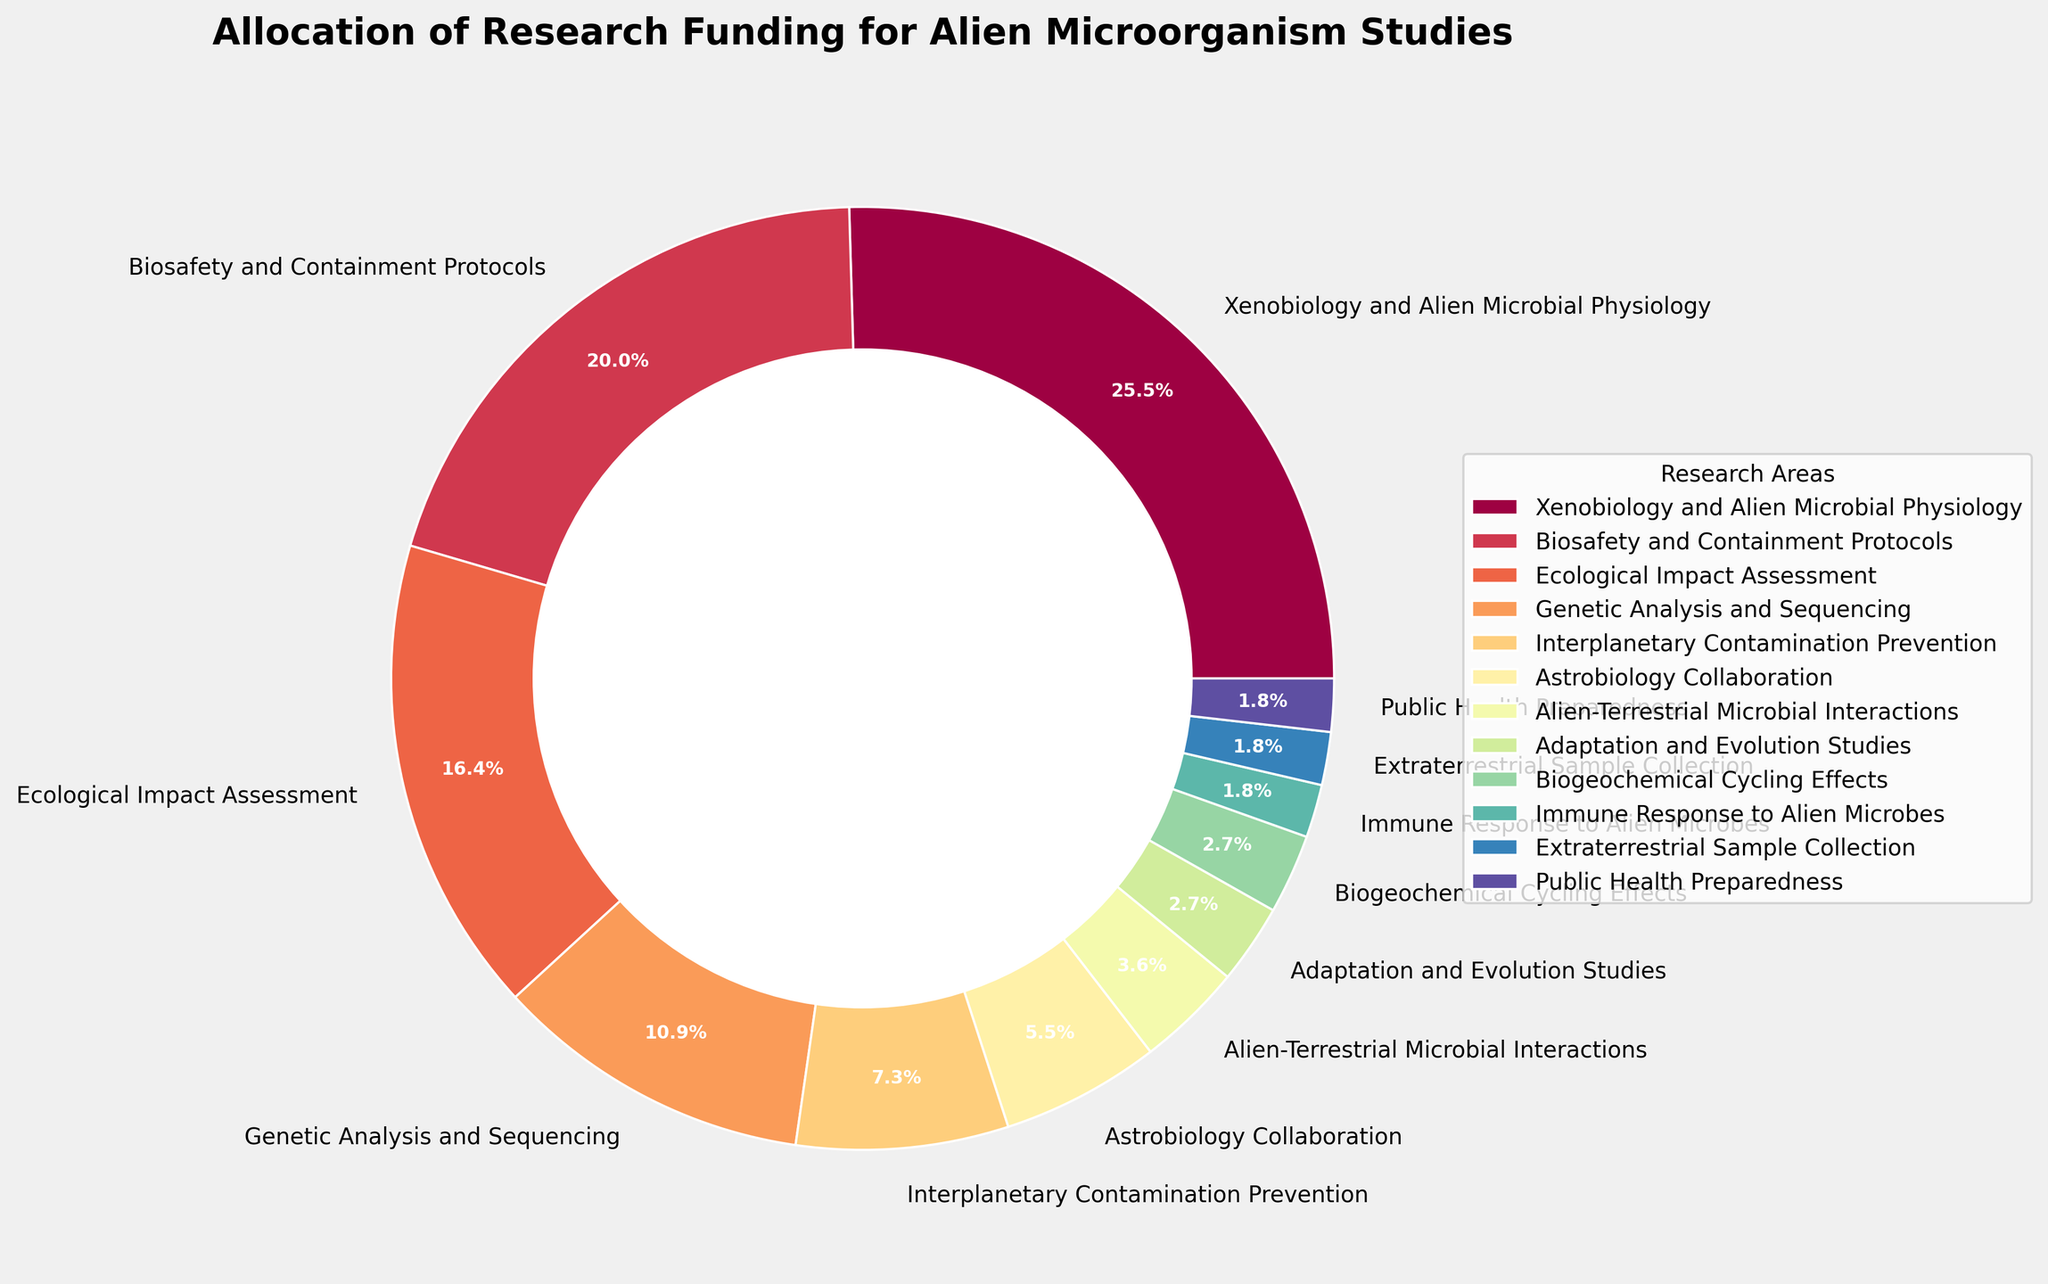What's the largest allocation of research funding among the different aspects of alien microorganism studies? The pie chart shows various research areas and their respective funding percentages. The sector labeled "Xenobiology and Alien Microbial Physiology" has the highest percentage.
Answer: Xenobiology and Alien Microbial Physiology How much more funding is allocated to Biosafety and Containment Protocols compared to Interplanetary Contamination Prevention? From the pie chart, Biosafety and Containment Protocols have 22% funding while Interplanetary Contamination Prevention has 8%. The difference is 22% - 8% = 14%.
Answer: 14% Which area receives less funding: Public Health Preparedness or Genetic Analysis and Sequencing? Referring to the pie chart, Public Health Preparedness has 2% funding, whereas Genetic Analysis and Sequencing has 12%. Therefore, Public Health Preparedness receives less funding.
Answer: Public Health Preparedness What's the total funding percentage allocated to the areas with the least amounts (less than or equal to 3%)? Areas with funding percentages less than or equal to 3% are: Alien-Terrestrial Microbial Interactions (4%), Adaptation and Evolution Studies (3%), Biogeochemical Cycling Effects (3%), Immune Response to Alien Microbes (2%), Extraterrestrial Sample Collection (2%), Public Health Preparedness (2%). Summing their percentages: 3 + 3 + 2 + 2 + 2 = 12%.
Answer: 12% How does the funding for Ecological Impact Assessment compare with Genetic Analysis and Sequencing? The pie chart shows Ecological Impact Assessment with 18% and Genetic Analysis and Sequencing with 12%. Ecological Impact Assessment has a higher funding percentage.
Answer: Ecological Impact Assessment has more funding Which area is allocated the third highest funding? From the visual inspection of the chart, the third largest slice corresponds to Ecological Impact Assessment at 18%.
Answer: Ecological Impact Assessment If funding for Biosafety and Containment Protocols increased by 6%, how would it compare to Xenobiology and Alien Microbial Physiology? Currently, Biosafety and Containment Protocols receive 22%. With an increase of 6%, it would be 22% + 6% = 28%, matching the current funding percentage for Xenobiology and Alien Microbial Physiology.
Answer: It would be equal What's the combined funding percentage for Genetic Analysis and Sequencing, and Astrobiology Collaboration? According to the pie chart, Genetic Analysis and Sequencing has 12% funding, and Astrobiology Collaboration has 6%. Adding these percentages yields: 12% + 6% = 18%.
Answer: 18% Which research area has twice the funding percentage of Public Health Preparedness? Public Health Preparedness has 2% funding. Alien-Terrestrial Microbial Interactions receives 4%, which is double.
Answer: Alien-Terrestrial Microbial Interactions What's the sum of the funding percentages for Interplanetary Contamination Prevention, Astrobiology Collaboration, and Alien-Terrestrial Microbial Interactions? On the chart, Interplanetary Contamination Prevention is 8%, Astrobiology Collaboration is 6%, and Alien-Terrestrial Microbial Interactions is 4%. Summing these: 8% + 6% + 4% = 18%.
Answer: 18% 